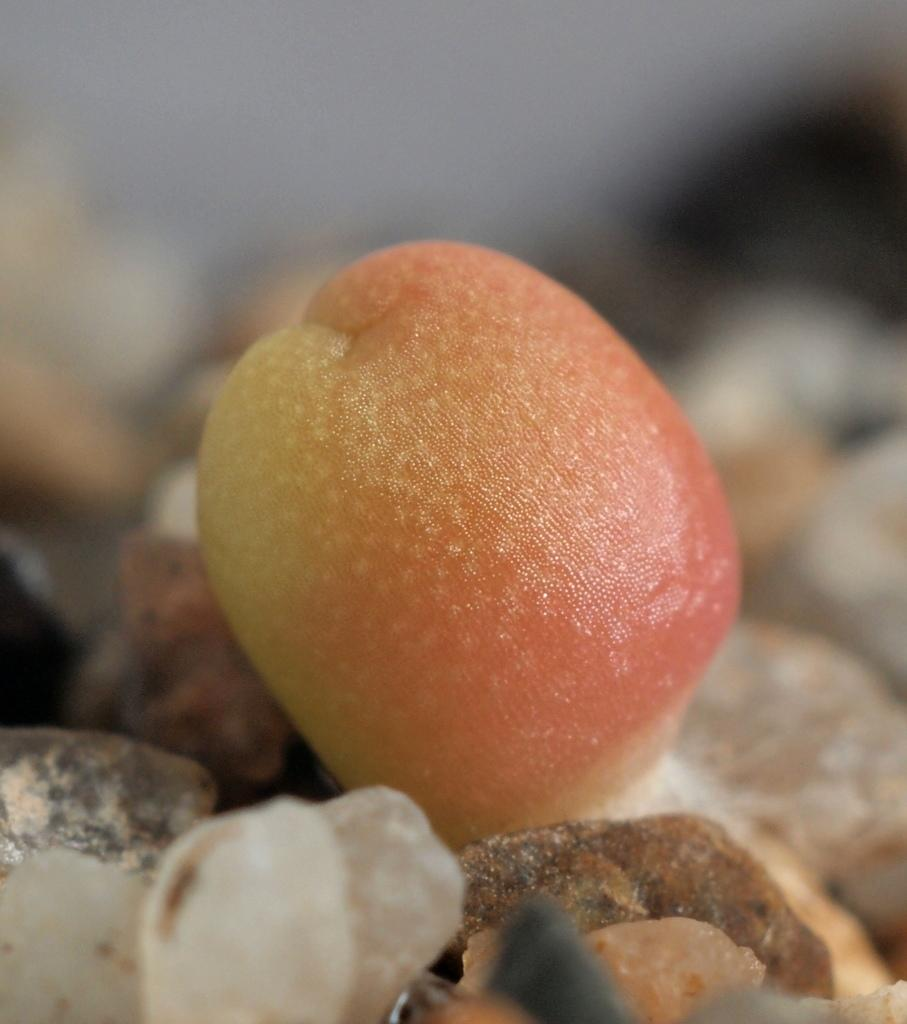What type of food is present in the image? There is a fruit in the image. Where is the fruit located? The fruit is on rocks. Can you describe the background of the image? The background of the image is blurred. Can you hear the fruit whistling in the image? There is no whistling in the image, as it features a fruit on rocks with a blurred background. 